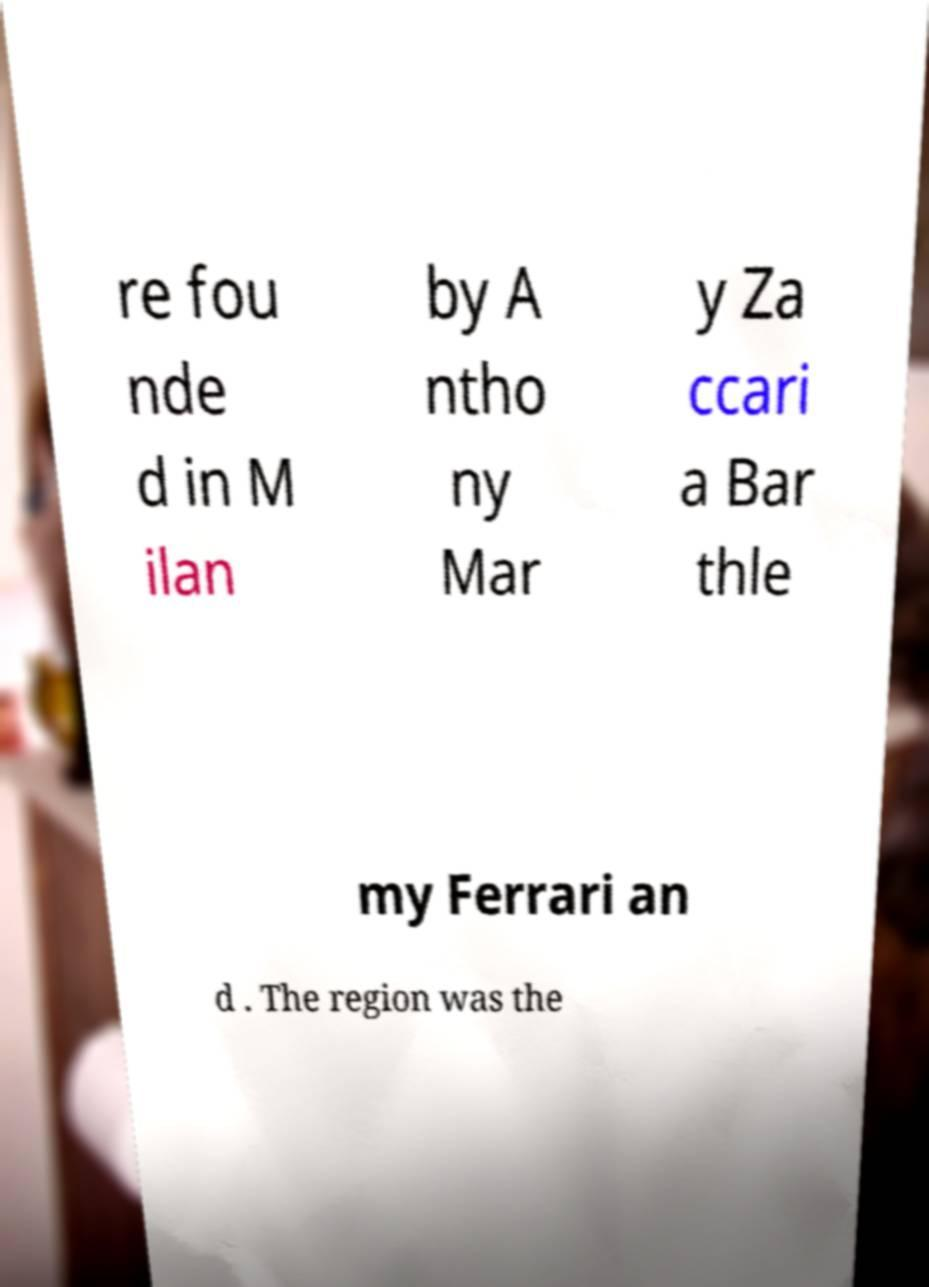Please identify and transcribe the text found in this image. re fou nde d in M ilan by A ntho ny Mar y Za ccari a Bar thle my Ferrari an d . The region was the 